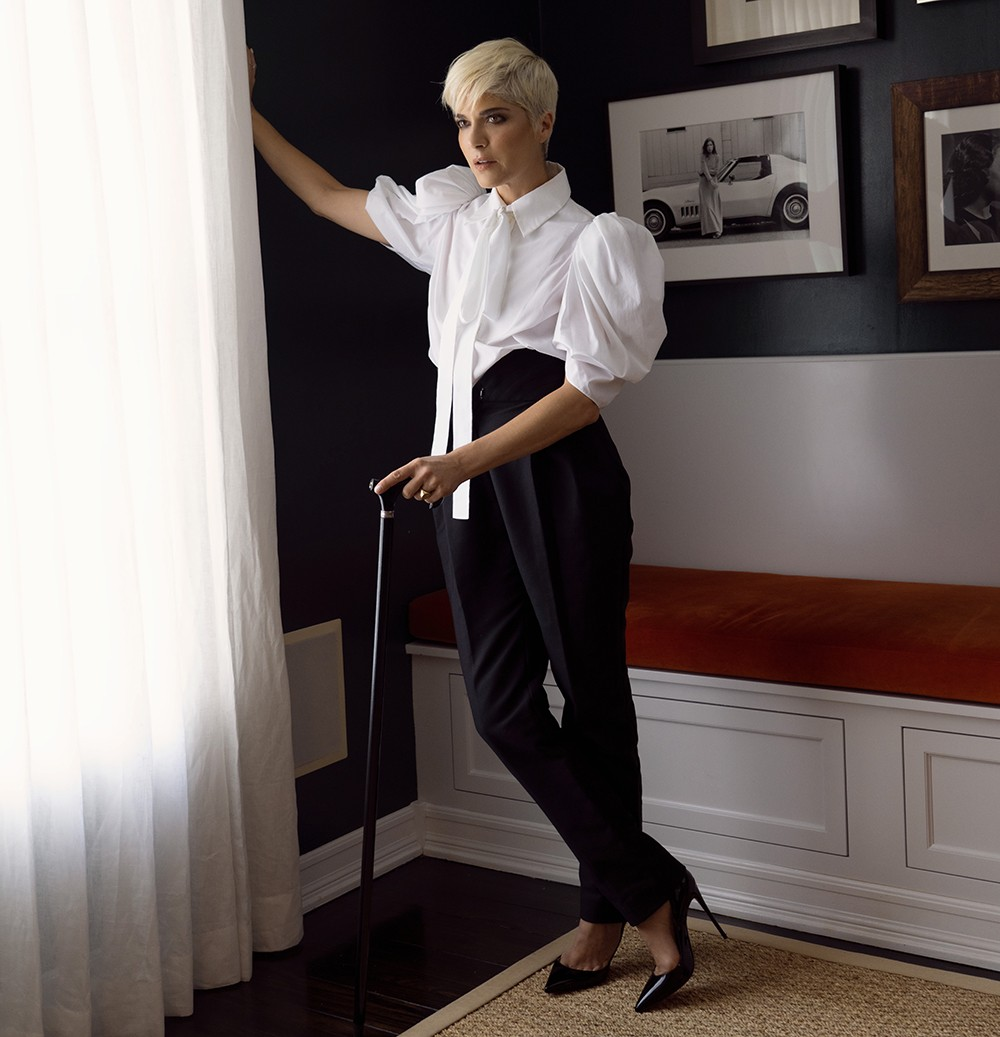If the cane were a magical object, what powers would it possess? If the cane were a magical object, it would possess the power of healing and strength. Whenever the holder touched the cane, they would feel a surge of energy and resilience, enabling them to overcome any physical or emotional challenge. It could also possess the ability to reveal hidden truths, glowing softly when near secrets or untold stories. The cane would guide its holder, offering wisdom and insight, making them stronger with every step they take forward. 